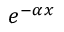<formula> <loc_0><loc_0><loc_500><loc_500>e ^ { - \alpha x }</formula> 